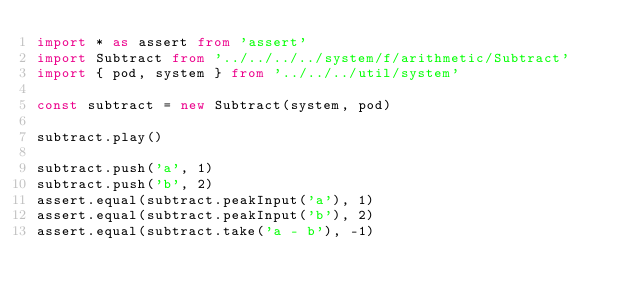Convert code to text. <code><loc_0><loc_0><loc_500><loc_500><_TypeScript_>import * as assert from 'assert'
import Subtract from '../../../../system/f/arithmetic/Subtract'
import { pod, system } from '../../../util/system'

const subtract = new Subtract(system, pod)

subtract.play()

subtract.push('a', 1)
subtract.push('b', 2)
assert.equal(subtract.peakInput('a'), 1)
assert.equal(subtract.peakInput('b'), 2)
assert.equal(subtract.take('a - b'), -1)
</code> 